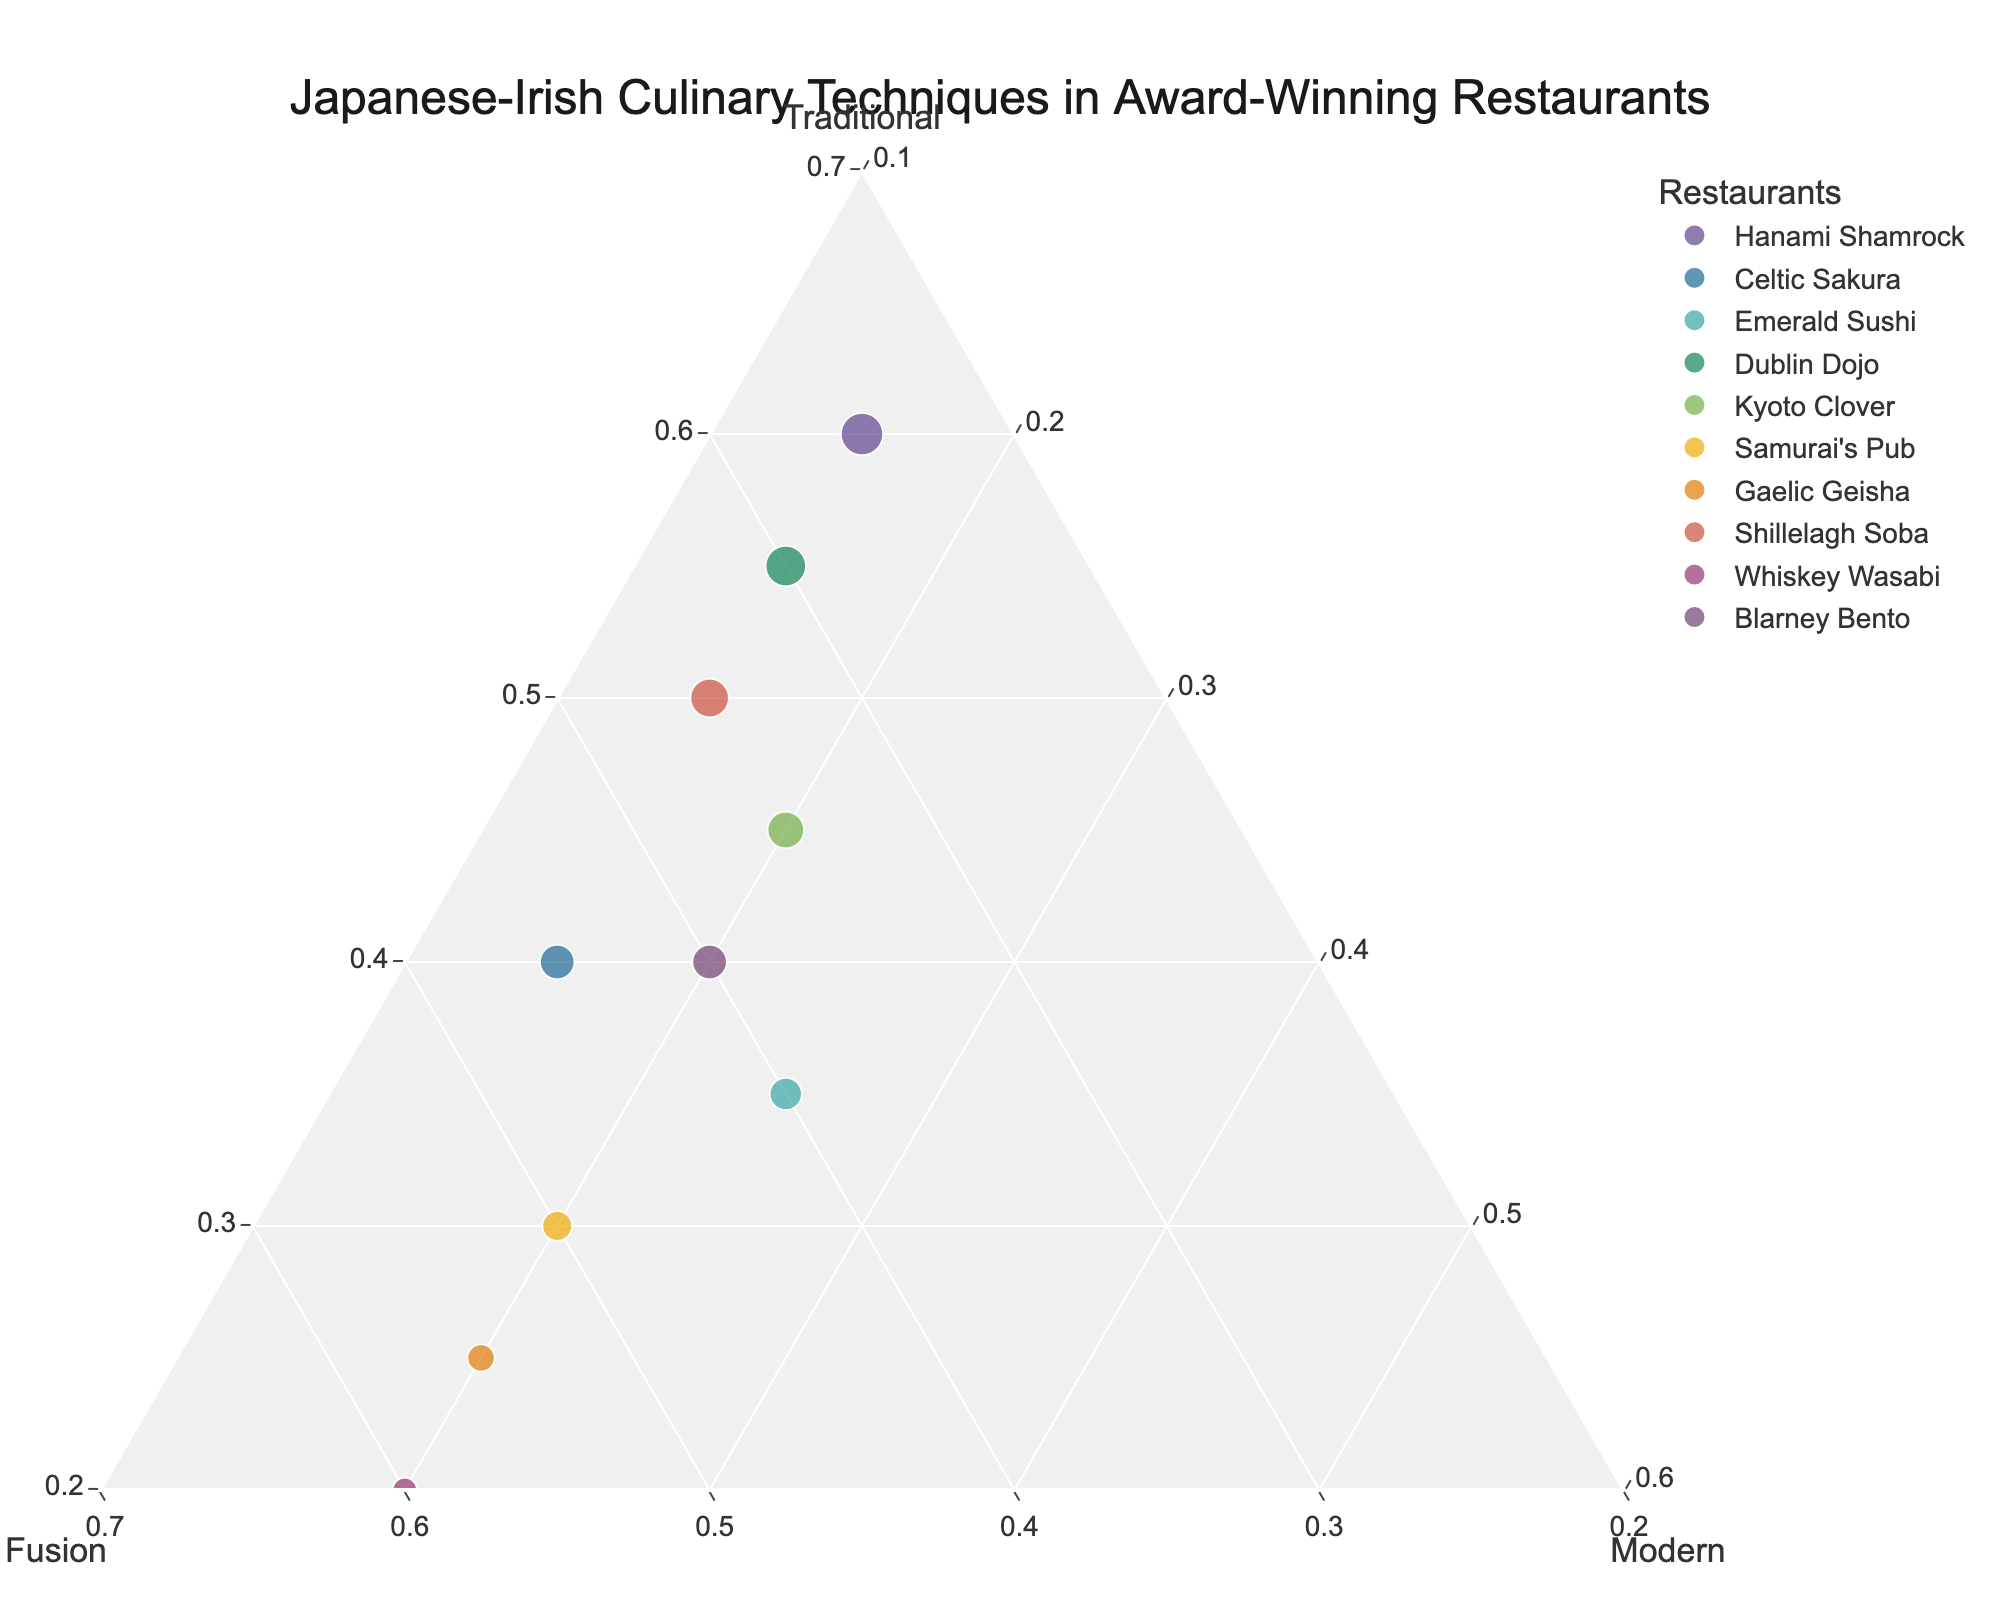How many restaurants are represented in the plot? There are 10 unique restaurant names listed in the data. By counting each unique restaurant symbol in the plot, we see 10 data points.
Answer: 10 Which restaurant has the highest proportion of Fusion techniques? By observing the plot, we can identify that Whiskey Wasabi has the highest position on the Fusion axis, indicating they have the highest proportion of Fusion techniques.
Answer: Whiskey Wasabi What is the range of Traditional technique proportions among the restaurants? The Traditional technique proportions range from the lowest at 20% (Whiskey Wasabi, Gaelic Geisha) to the highest at 60% (Hanami Shamrock). The range is calculated as 60 - 20 = 40%.
Answer: 40% Which two restaurants have an equal proportion of Modern techniques? By observing the Modern axis values, Samurai's Pub and Gaelic Geisha both have a Modern technique proportion of 20%.
Answer: Samurai's Pub, Gaelic Geisha Who has a greater focus on Traditional techniques, Hanami Shamrock or Dublin Dojo? Comparing the positions of Hanami Shamrock (60% Traditional) and Dublin Dojo (55% Traditional) on the Traditional axis, Hanami Shamrock has a higher proportion of Traditional techniques.
Answer: Hanami Shamrock Which restaurant has the lowest proportion of Traditional techniques but a higher proportion of Fusion over Modern techniques? By observing the plot, Whiskey Wasabi has the lowest Traditional at 20% and shows a higher proportion of Fusion (60%) compared to Modern (20%).
Answer: Whiskey Wasabi What is the average proportion of Modern techniques across all restaurants? Summing the Modern percentages (15 + 15 + 25 + 15 + 20 + 20 + 20 + 15 + 20 + 20), we get a total of 185%. Dividing by 10 restaurants, the average is 185/10 = 18.5%.
Answer: 18.5% If you were to choose a restaurant with balanced technique proportions, which one would be closest to this preference? Blarney Bento has proportions of 40% Traditional, 40% Fusion, and 20% Modern, which appear the most balanced comparatively.
Answer: Blarney Bento Among Celtic Sakura and Emerald Sushi, which utilizes a higher combination of Traditional and Fusion techniques? Combining the proportions for Celtic Sakura (40% Traditional + 45% Fusion = 85%) and Emerald Sushi (35% Traditional + 40% Fusion = 75%), Celtic Sakura utilizes a higher combination of Traditional and Fusion techniques.
Answer: Celtic Sakura 